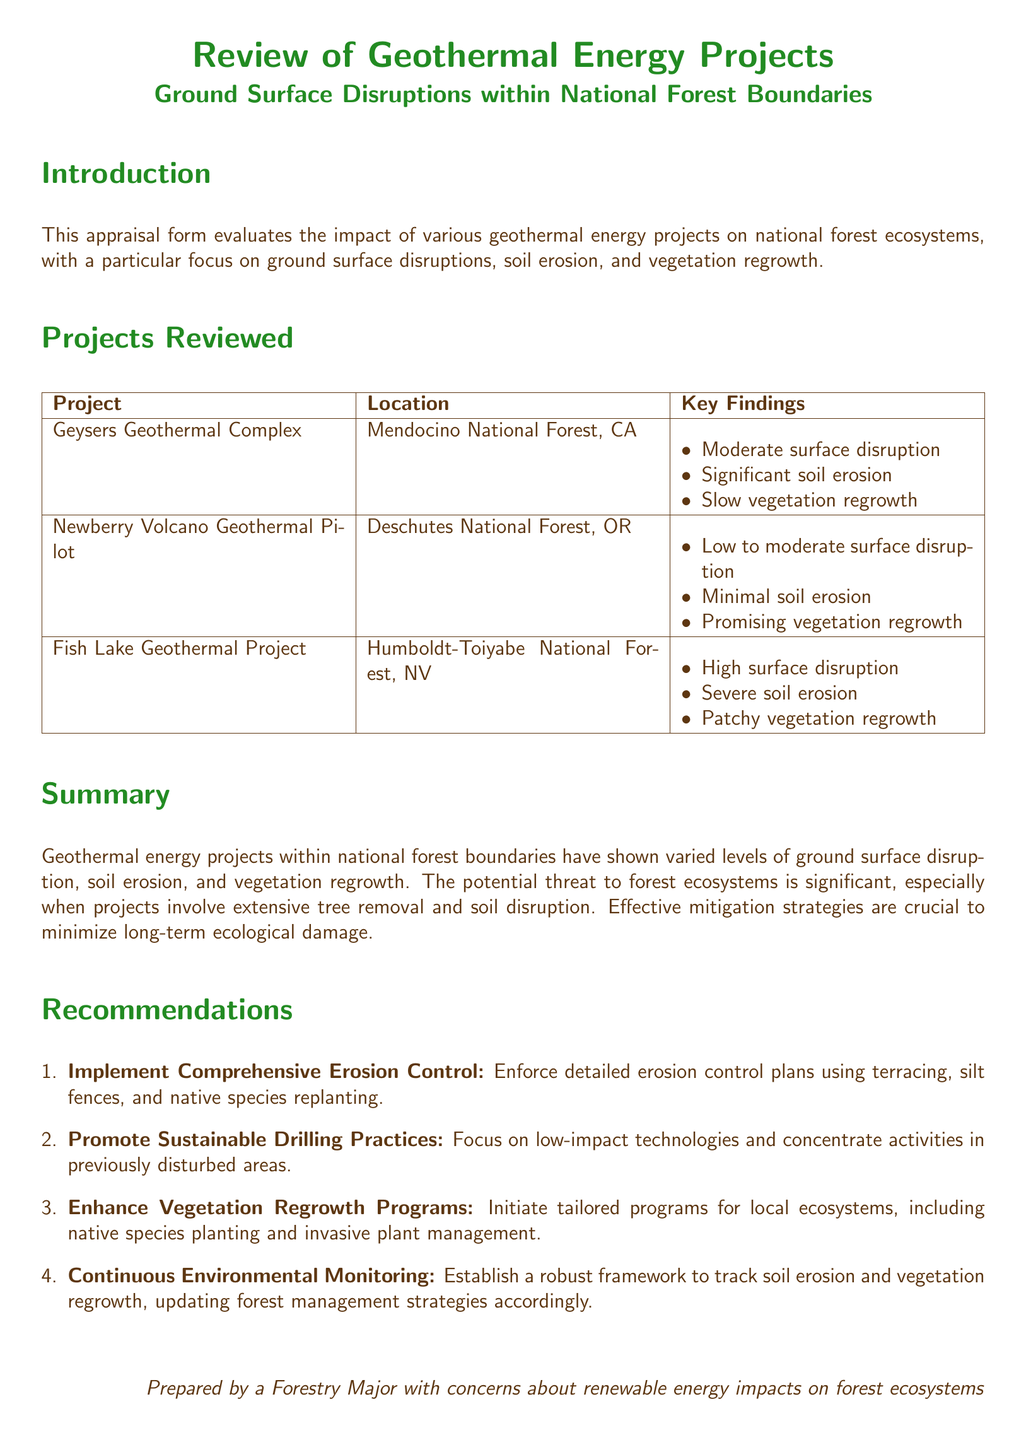What is the primary focus of the appraisal form? The appraisal form evaluates the impact of geothermal energy projects on national forest ecosystems, focusing on ground surface disruptions, soil erosion, and vegetation regrowth.
Answer: Ground surface disruptions, soil erosion, and vegetation regrowth How many geothermal projects are reviewed in the document? The document lists three geothermal projects reviewed.
Answer: Three Which project had the highest surface disruption? The Fish Lake Geothermal Project is noted for having high surface disruption.
Answer: Fish Lake Geothermal Project What recommendation involves species management? The recommendation suggesting tailored programs for local ecosystems involves species management, including native species planting and invasive plant management.
Answer: Enhance Vegetation Regrowth Programs What was a key finding for the Geysers Geothermal Complex? A key finding for the Geysers Geothermal Complex is significant soil erosion.
Answer: Significant soil erosion What is one of the proposed methods for erosion control? The document recommends using silt fences as one of the erosion control methods.
Answer: Silt fences 